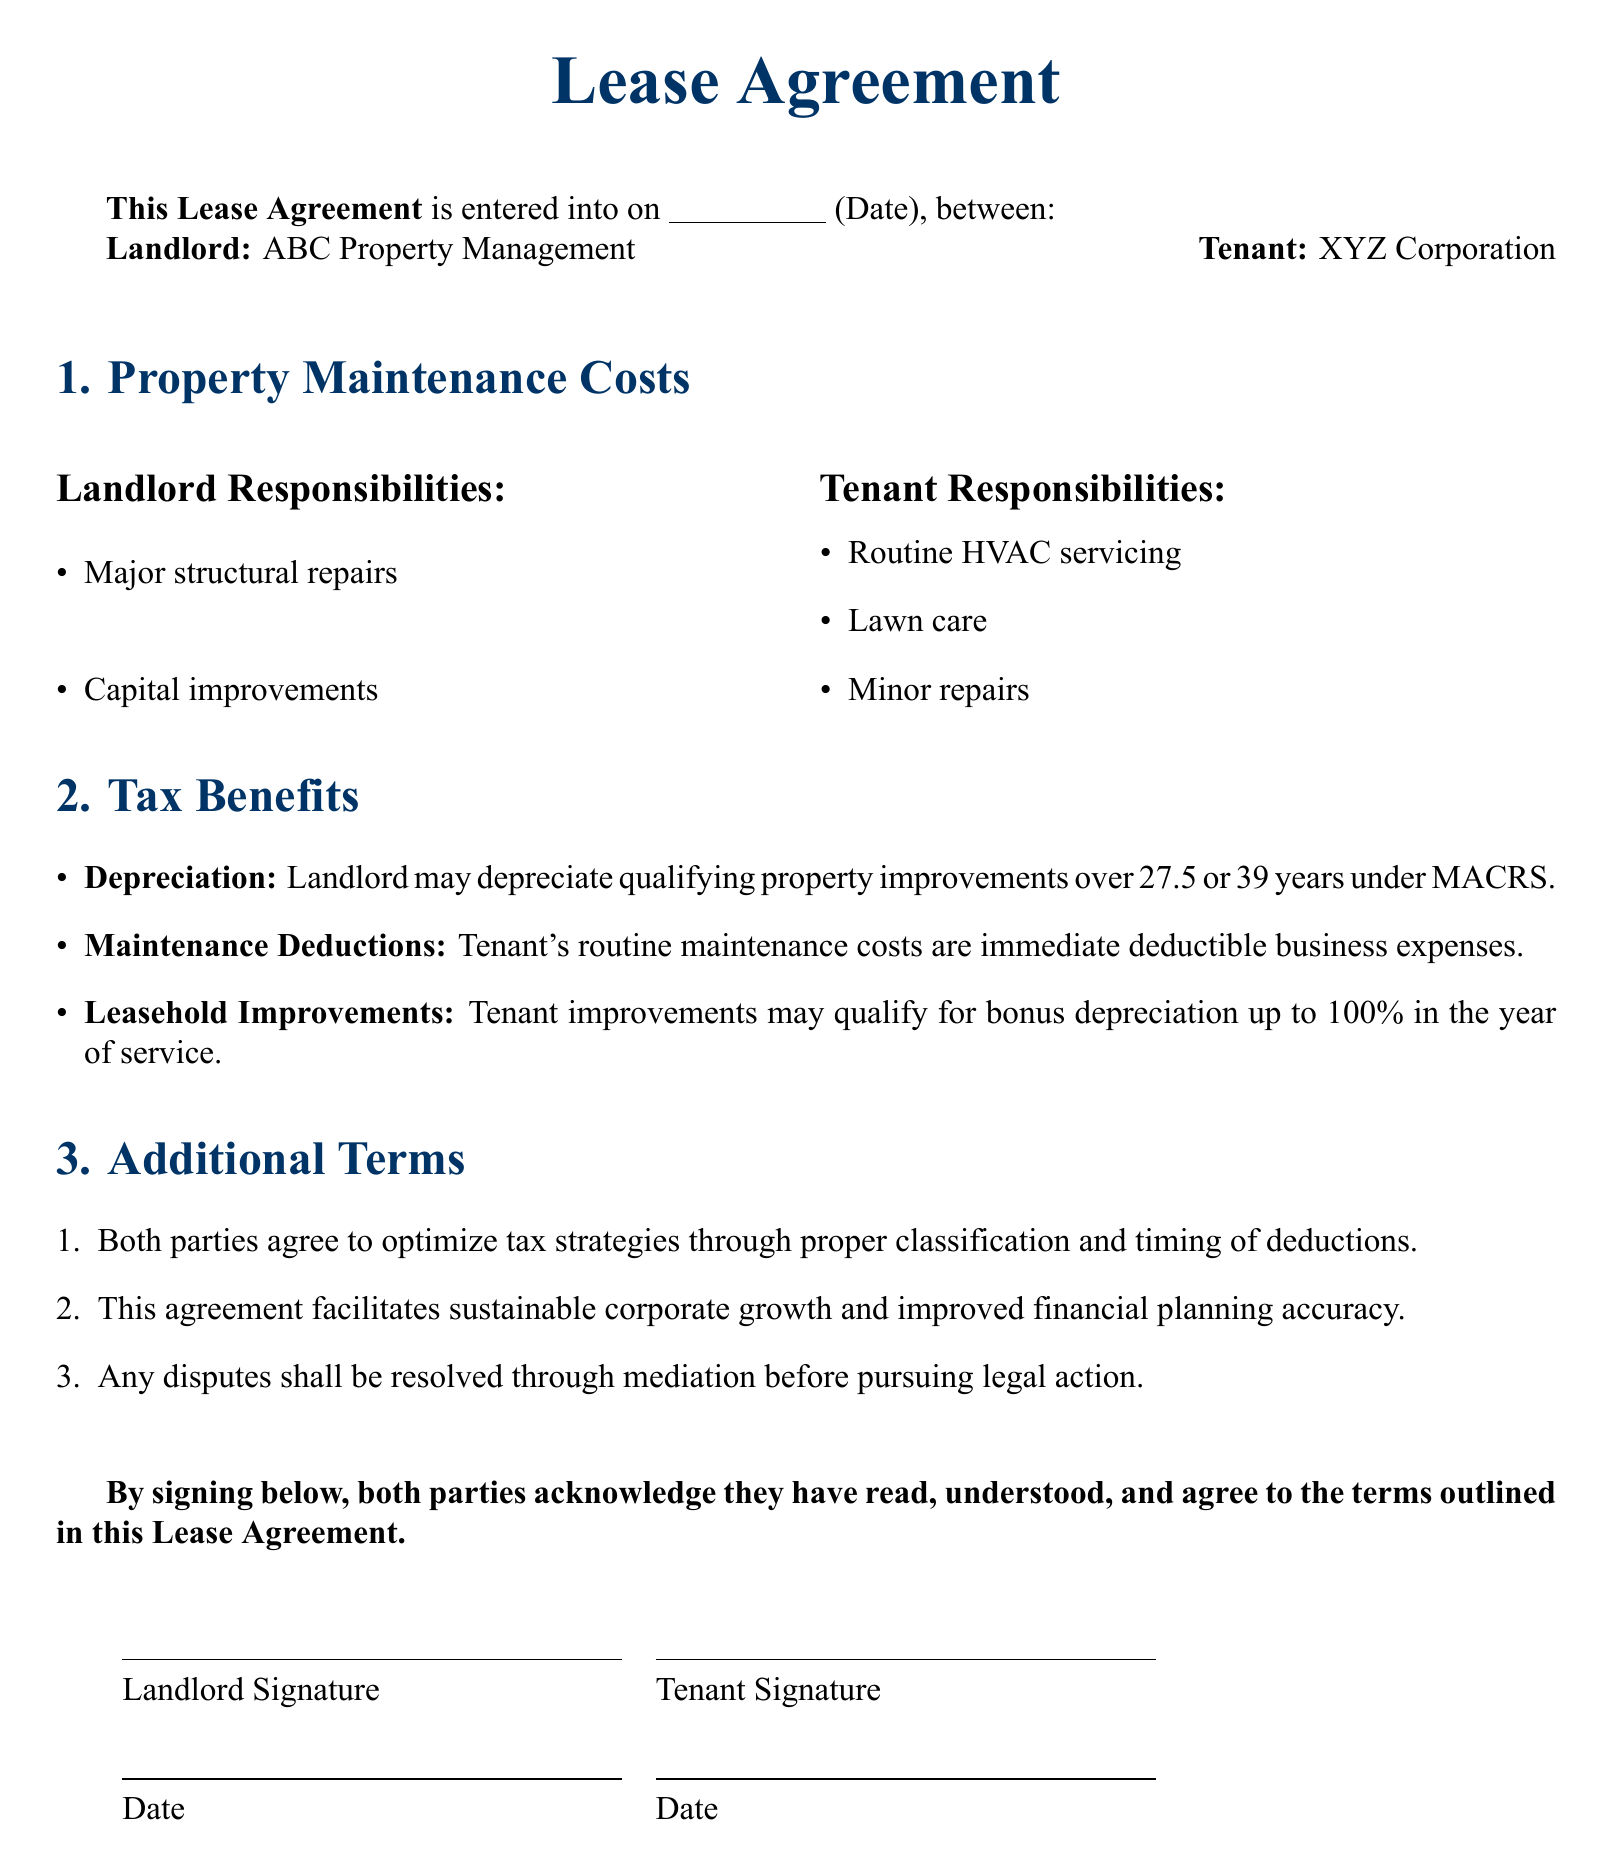What date was the Lease Agreement entered into? The date of the agreement is specified in the blank line after "entered into on".
Answer: (Date) Who is the Landlord? The document identifies ABC Property Management as the Landlord.
Answer: ABC Property Management What are the Tenant's routine maintenance responsibilities? The document lists routine HVAC servicing, lawn care, and minor repairs as tenant responsibilities.
Answer: Routine HVAC servicing, lawn care, minor repairs What is the depreciation period for qualifying property improvements under MACRS? The lease mentions 27.5 or 39 years for depreciation of qualifying property improvements.
Answer: 27.5 or 39 years What tax benefits are available for tenant improvements? According to the agreement, tenant improvements may qualify for bonus depreciation up to 100% in the year of service.
Answer: Bonus depreciation up to 100% What dispute resolution method is mentioned in the agreement? The document states that disputes shall be resolved through mediation before pursuing legal action.
Answer: Mediation What type of agreement does this Lease encourage? The agreement indicates that it facilitates sustainable corporate growth and improved financial planning accuracy.
Answer: Sustainable corporate growth and improved financial planning accuracy What is one of the landlord's responsibilities? The lease specifies that major structural repairs are the landlord's responsibility.
Answer: Major structural repairs What agreement do both parties make regarding tax strategies? The lease states both parties agree to optimize tax strategies through proper classification and timing of deductions.
Answer: Optimize tax strategies 